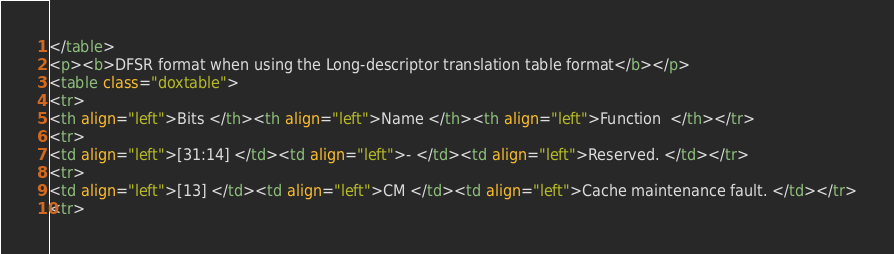Convert code to text. <code><loc_0><loc_0><loc_500><loc_500><_HTML_></table>
<p><b>DFSR format when using the Long-descriptor translation table format</b></p>
<table class="doxtable">
<tr>
<th align="left">Bits </th><th align="left">Name </th><th align="left">Function  </th></tr>
<tr>
<td align="left">[31:14] </td><td align="left">- </td><td align="left">Reserved. </td></tr>
<tr>
<td align="left">[13] </td><td align="left">CM </td><td align="left">Cache maintenance fault. </td></tr>
<tr></code> 